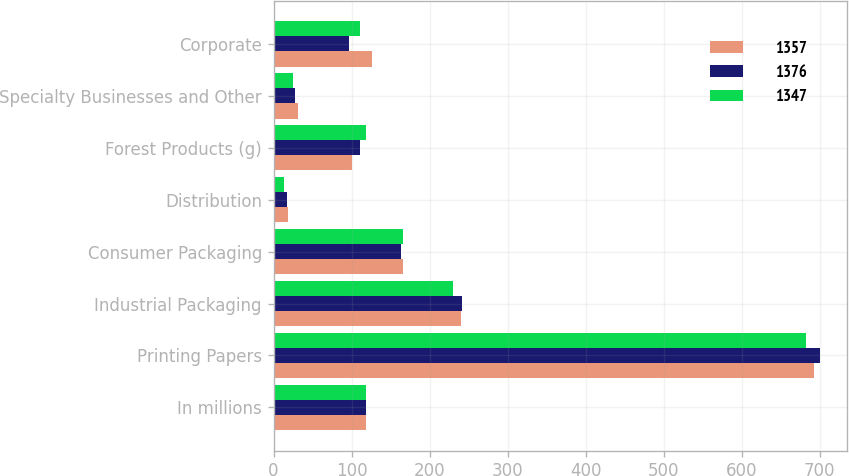Convert chart to OTSL. <chart><loc_0><loc_0><loc_500><loc_500><stacked_bar_chart><ecel><fcel>In millions<fcel>Printing Papers<fcel>Industrial Packaging<fcel>Consumer Packaging<fcel>Distribution<fcel>Forest Products (g)<fcel>Specialty Businesses and Other<fcel>Corporate<nl><fcel>1357<fcel>119<fcel>693<fcel>240<fcel>166<fcel>19<fcel>101<fcel>31<fcel>126<nl><fcel>1376<fcel>119<fcel>700<fcel>241<fcel>164<fcel>17<fcel>111<fcel>27<fcel>97<nl><fcel>1347<fcel>119<fcel>682<fcel>230<fcel>166<fcel>14<fcel>119<fcel>25<fcel>111<nl></chart> 